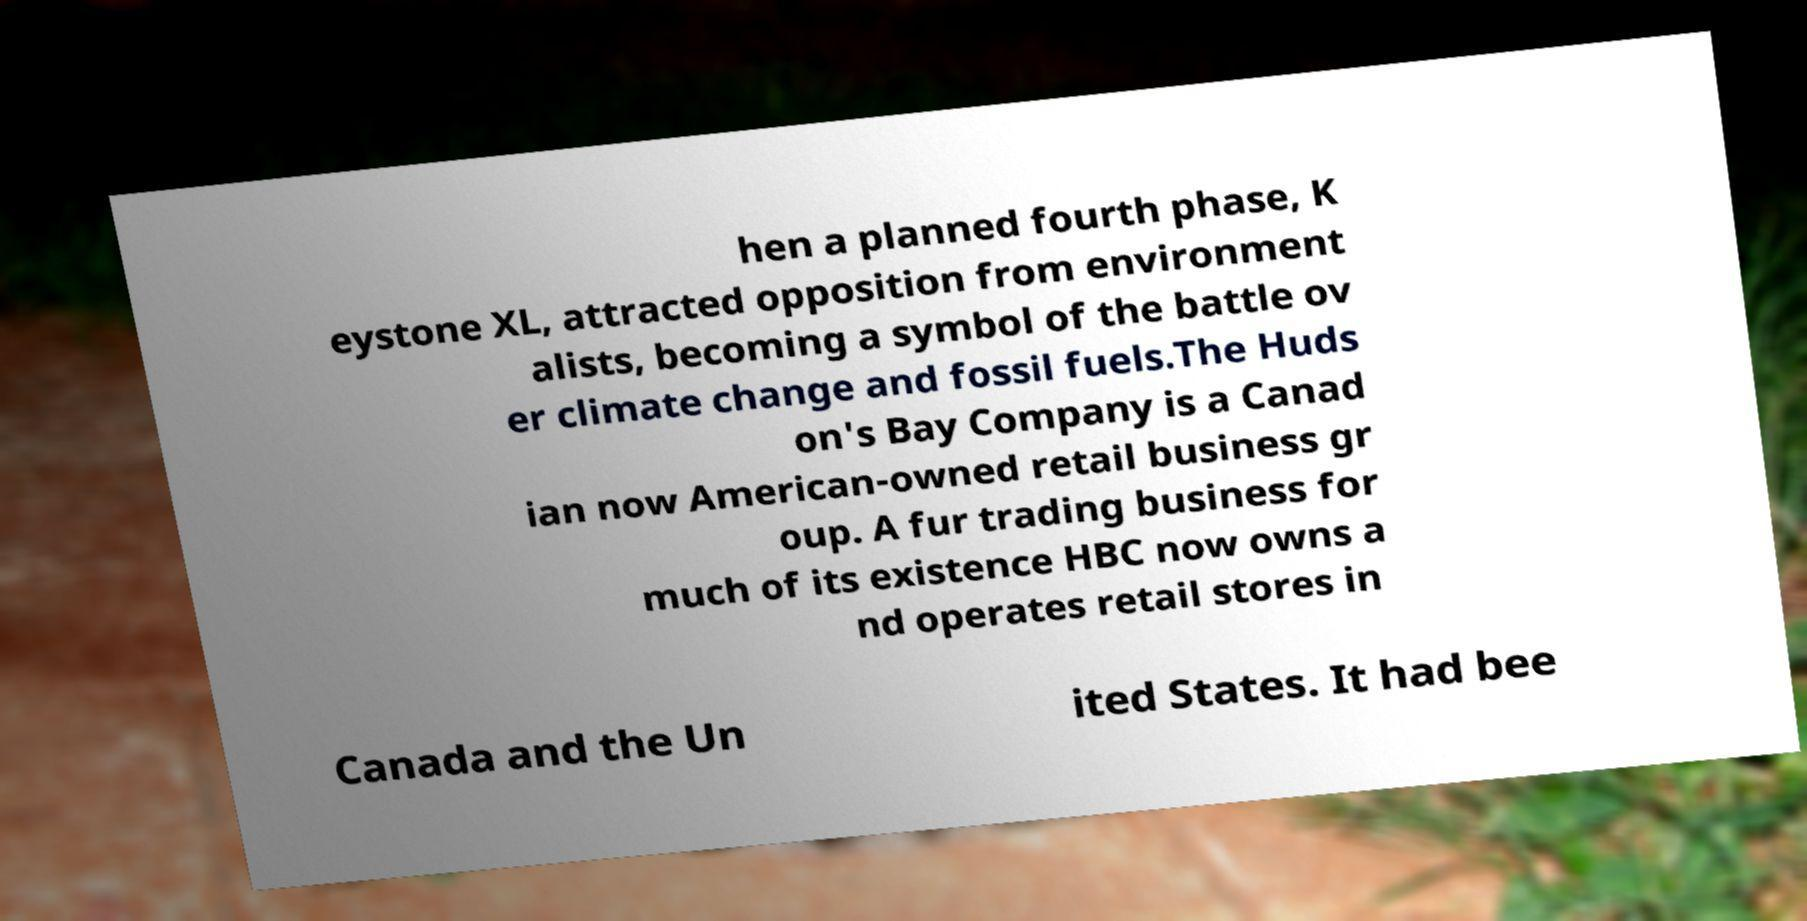Please read and relay the text visible in this image. What does it say? hen a planned fourth phase, K eystone XL, attracted opposition from environment alists, becoming a symbol of the battle ov er climate change and fossil fuels.The Huds on's Bay Company is a Canad ian now American-owned retail business gr oup. A fur trading business for much of its existence HBC now owns a nd operates retail stores in Canada and the Un ited States. It had bee 